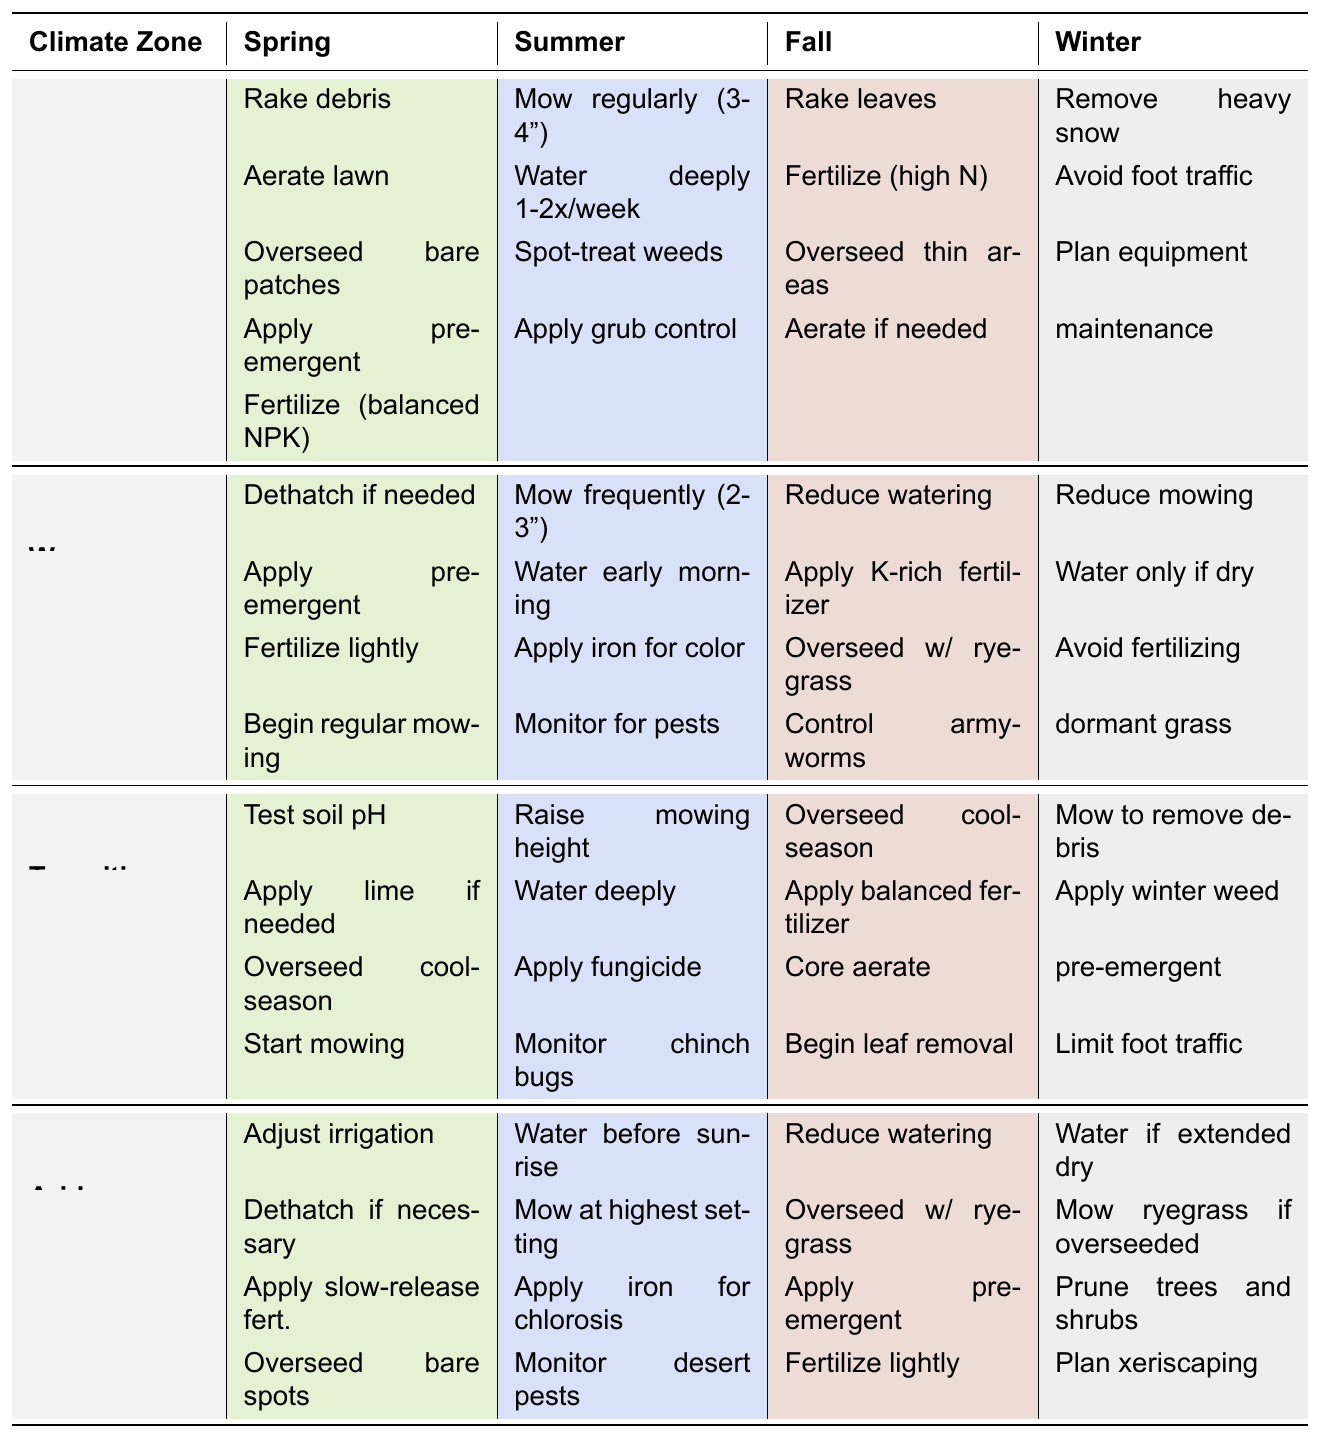What tasks should I perform in the spring for a Warm-season lawn? Looking at the table, under the Warm-season climate zone and Spring season, the tasks listed are: dethatch if needed, apply pre-emergent herbicide, fertilize lightly, and begin regular mowing.
Answer: Dethatch if needed, apply pre-emergent herbicide, fertilize lightly, begin regular mowing How many total tasks are listed for the Cool-season in the Fall? In the Fall for the Cool-season zone, there are four tasks listed: rake leaves, fertilize with high nitrogen, overseed thin areas, and aerate if needed, totaling four tasks.
Answer: Four tasks Is it true that mowing is performed at different heights in the Warm-season and Transition zones during the summer? For Warm-season, the mowing height is 2-3 inches, and for Transition, it is raised. Thus, it is true that they are performed at different heights.
Answer: Yes, it is true What tasks are recommended during the Winter for the Arid climate zone, and how do they compare to the Winter tasks for the Cool-season? In the Arid zone during Winter, the tasks are: water only during extended dry periods, mow ryegrass if overseeded, prune trees and shrubs, and plan xeriscaping additions. For Cool-season, the tasks are: remove heavy snow loads, avoid foot traffic on frozen grass, and plan for spring equipment maintenance. All four tasks for Arid are focused on water management and pruning, while Cool-season tasks are about snow and frozen ground management.
Answer: Arid tasks focus on water management and pruning; Cool-season tasks involve snow and frozen grass management Which climate zone has the least number of tasks to perform in the Summer? Analyzing the tasks for Summer in each climate zone, the Cool-season has four tasks, Warm-season has four tasks, Transition has four tasks, and Arid also has four tasks, indicating they are evenly matched.
Answer: None; all have four tasks How many total tasks are there across all climate zones for Spring? Summing the tasks for Spring in each climate zone: Cool-season has five, Warm-season has four, Transition has four, and Arid has four. Thus, the total is 5 + 4 + 4 + 4 = 17.
Answer: 17 tasks 